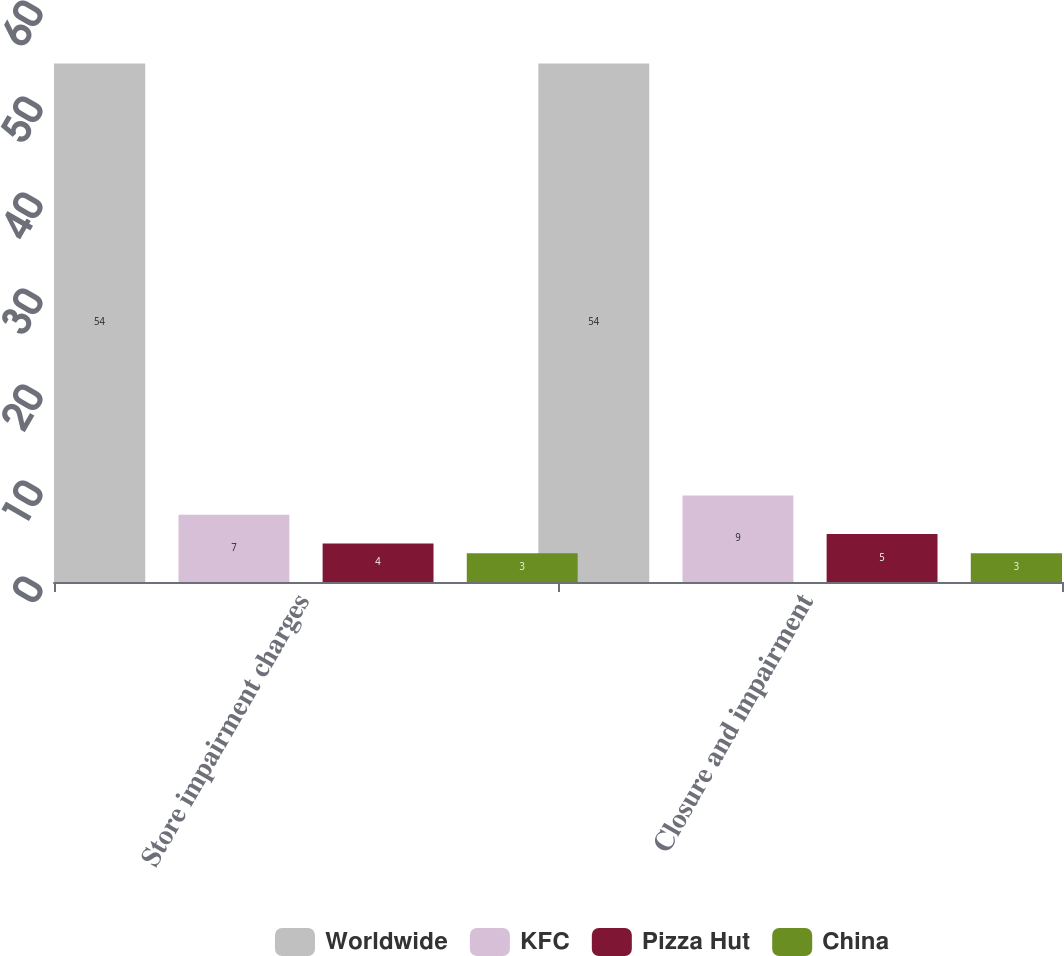Convert chart to OTSL. <chart><loc_0><loc_0><loc_500><loc_500><stacked_bar_chart><ecel><fcel>Store impairment charges<fcel>Closure and impairment<nl><fcel>Worldwide<fcel>54<fcel>54<nl><fcel>KFC<fcel>7<fcel>9<nl><fcel>Pizza Hut<fcel>4<fcel>5<nl><fcel>China<fcel>3<fcel>3<nl></chart> 